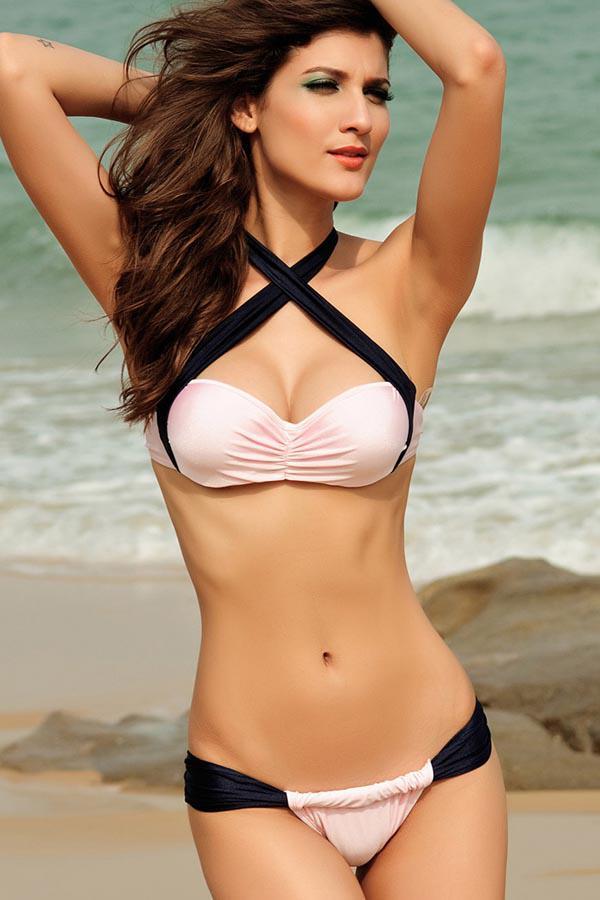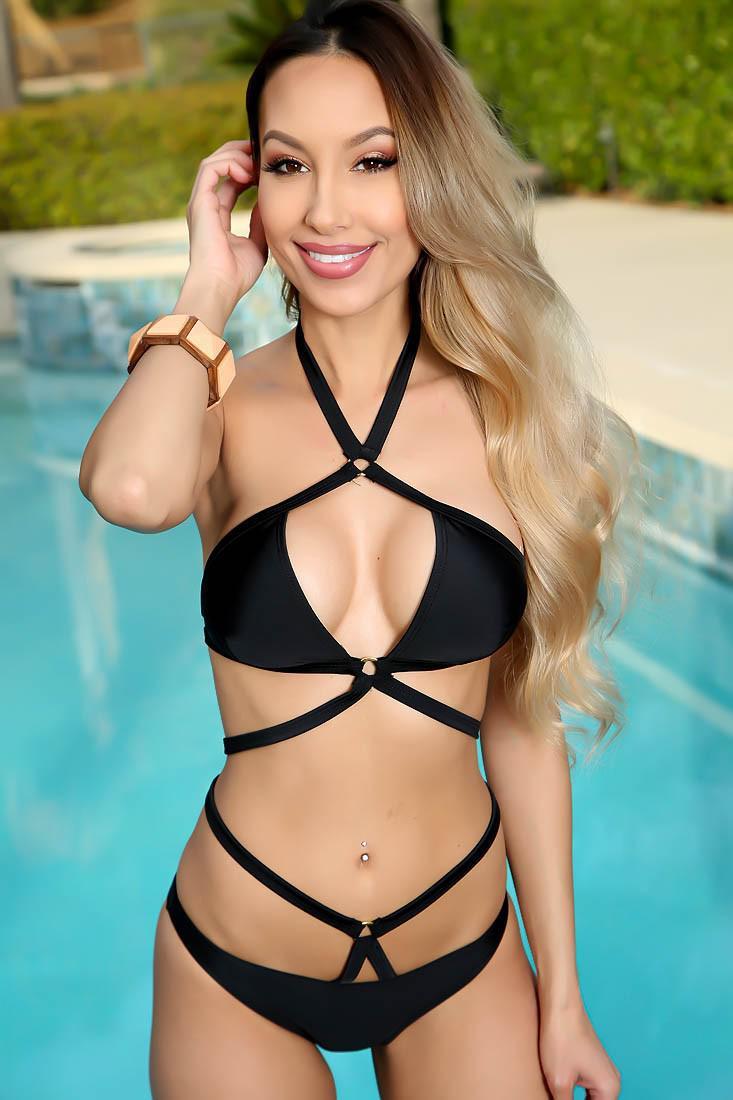The first image is the image on the left, the second image is the image on the right. For the images displayed, is the sentence "An image shows a girl in a nearly all-white bikini in front of a pool." factually correct? Answer yes or no. No. 